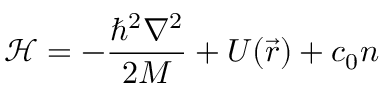<formula> <loc_0><loc_0><loc_500><loc_500>\mathcal { H } = - \frac { \hbar { ^ } { 2 } \nabla ^ { 2 } } { 2 M } + U ( \vec { r } ) + c _ { 0 } n</formula> 